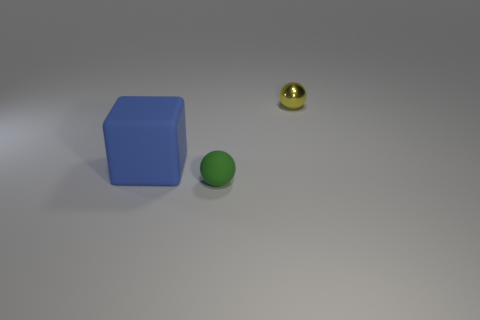Is the shape of the green rubber thing that is on the right side of the blue block the same as the thing to the right of the green matte object?
Offer a very short reply. Yes. There is a big matte object; are there any large rubber blocks right of it?
Offer a very short reply. No. What is the color of the other tiny object that is the same shape as the metal thing?
Your response must be concise. Green. Is there anything else that has the same shape as the blue thing?
Your response must be concise. No. What is the material of the thing that is behind the block?
Offer a very short reply. Metal. What size is the green thing that is the same shape as the yellow thing?
Your answer should be very brief. Small. How many yellow objects have the same material as the small yellow sphere?
Your answer should be very brief. 0. What number of objects are objects behind the small rubber ball or tiny things to the left of the tiny shiny object?
Your answer should be very brief. 3. Are there fewer spheres left of the green matte sphere than blocks?
Make the answer very short. Yes. Is there a yellow shiny object of the same size as the green sphere?
Your answer should be very brief. Yes. 